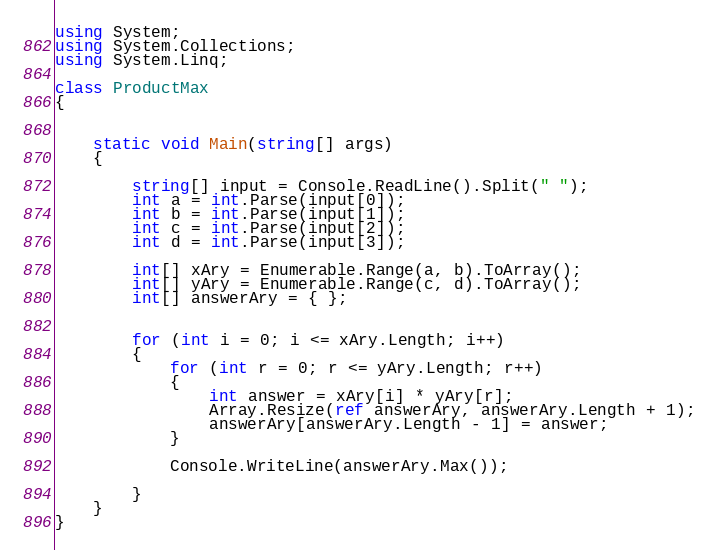<code> <loc_0><loc_0><loc_500><loc_500><_C#_>using System;
using System.Collections;
using System.Linq;

class ProductMax
{


    static void Main(string[] args)
    {

        string[] input = Console.ReadLine().Split(" ");
        int a = int.Parse(input[0]);
        int b = int.Parse(input[1]);
        int c = int.Parse(input[2]);
        int d = int.Parse(input[3]);

        int[] xAry = Enumerable.Range(a, b).ToArray();
        int[] yAry = Enumerable.Range(c, d).ToArray();
        int[] answerAry = { };


        for (int i = 0; i <= xAry.Length; i++)
        {
            for (int r = 0; r <= yAry.Length; r++)
            {
                int answer = xAry[i] * yAry[r];
                Array.Resize(ref answerAry, answerAry.Length + 1);
                answerAry[answerAry.Length - 1] = answer;
            }

            Console.WriteLine(answerAry.Max());

        }
    }
}
</code> 